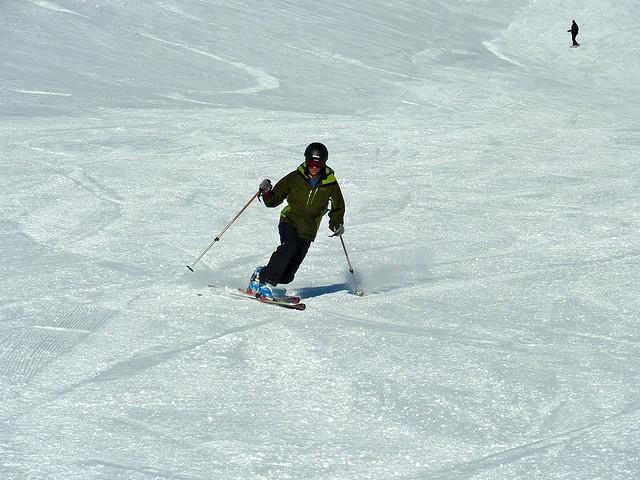How old is he?
Answer briefly. 25. What color boots does the man have on?
Short answer required. Blue. What country is this in?
Quick response, please. Usa. 